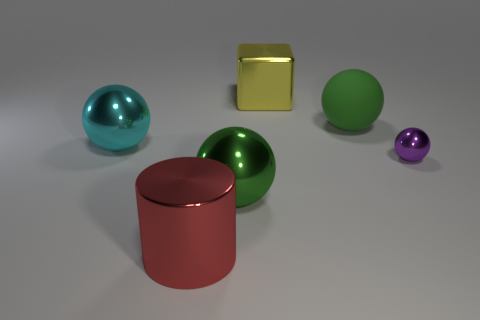Subtract all red spheres. Subtract all red cubes. How many spheres are left? 4 Add 4 yellow metallic blocks. How many objects exist? 10 Subtract all spheres. How many objects are left? 2 Add 3 large red metal cylinders. How many large red metal cylinders exist? 4 Subtract 0 brown blocks. How many objects are left? 6 Subtract all large green shiny balls. Subtract all big green matte balls. How many objects are left? 4 Add 5 yellow metallic objects. How many yellow metallic objects are left? 6 